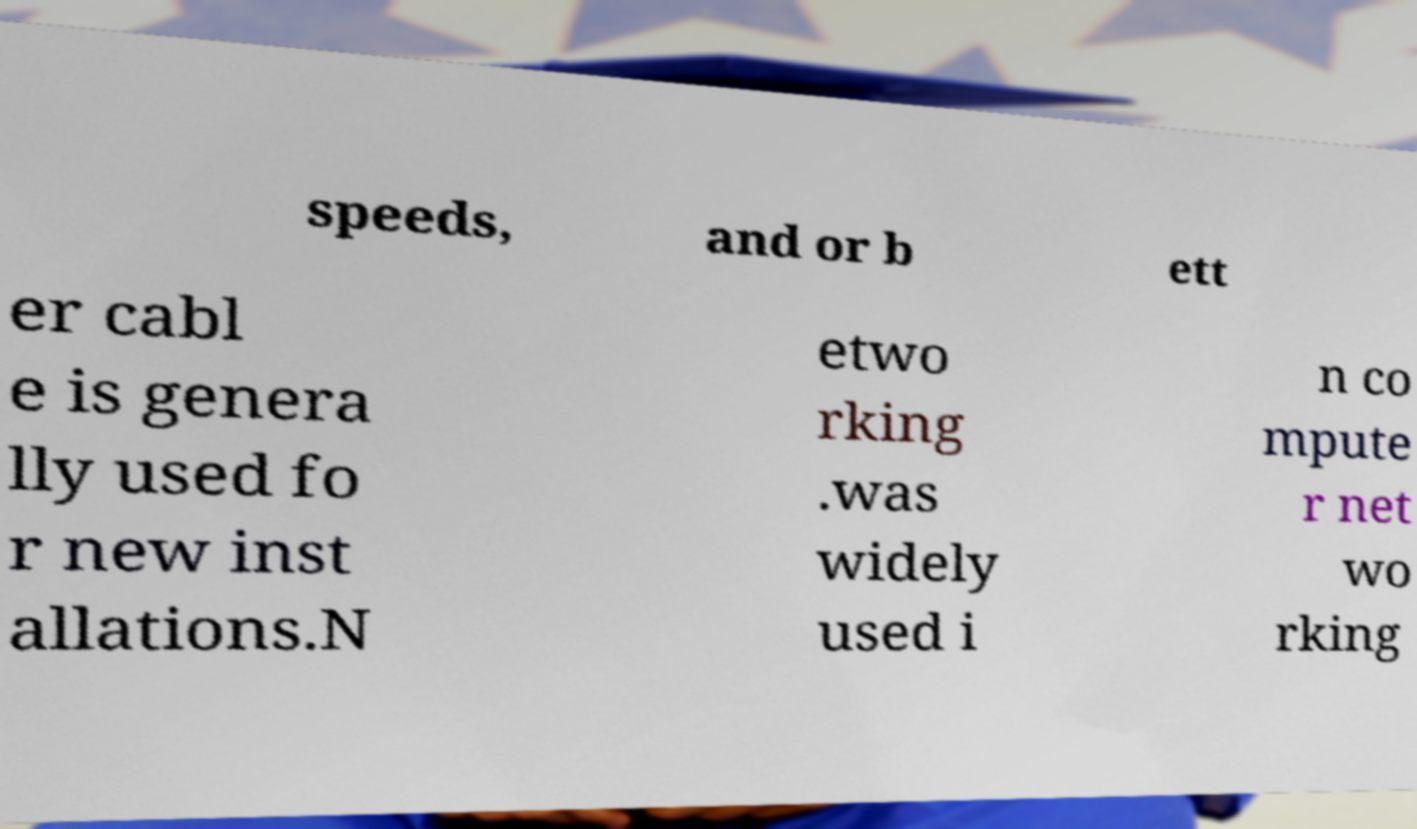Could you extract and type out the text from this image? speeds, and or b ett er cabl e is genera lly used fo r new inst allations.N etwo rking .was widely used i n co mpute r net wo rking 